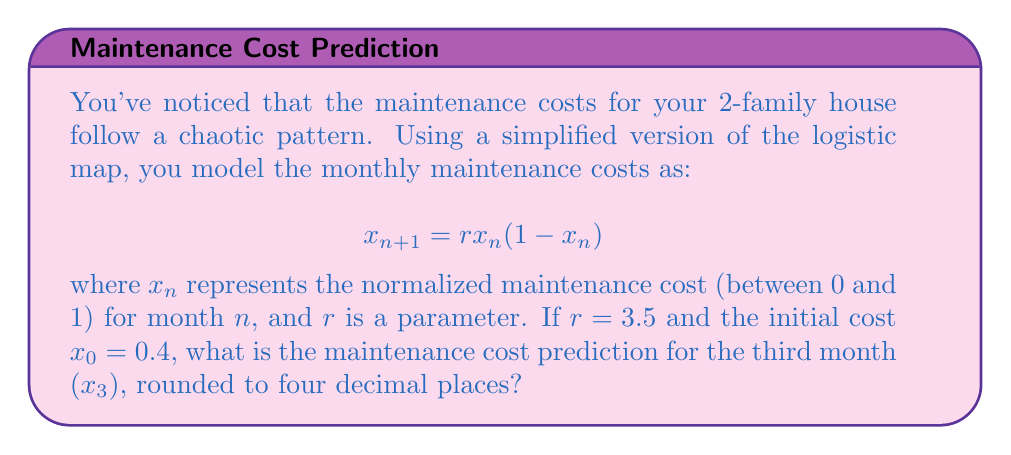Provide a solution to this math problem. To solve this problem, we need to iterate the logistic map equation three times:

1. First, calculate $x_1$:
   $$x_1 = 3.5 \cdot 0.4(1-0.4) = 3.5 \cdot 0.4 \cdot 0.6 = 0.84$$

2. Next, calculate $x_2$:
   $$x_2 = 3.5 \cdot 0.84(1-0.84) = 3.5 \cdot 0.84 \cdot 0.16 = 0.4704$$

3. Finally, calculate $x_3$:
   $$x_3 = 3.5 \cdot 0.4704(1-0.4704) = 3.5 \cdot 0.4704 \cdot 0.5296 = 0.8719$$

4. Rounding to four decimal places:
   $$x_3 \approx 0.8719$$

This result shows how quickly the maintenance costs can change in a chaotic system, even with a simple model. The logistic map is known to exhibit chaotic behavior for certain parameter values, including $r = 3.5$, which makes long-term predictions challenging for a landlord.
Answer: 0.8719 